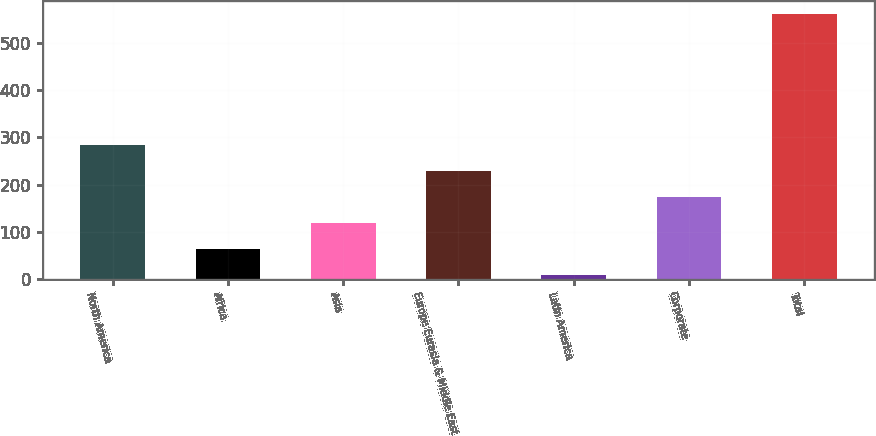Convert chart to OTSL. <chart><loc_0><loc_0><loc_500><loc_500><bar_chart><fcel>North America<fcel>Africa<fcel>Asia<fcel>Europe Eurasia & Middle East<fcel>Latin America<fcel>Corporate<fcel>Total<nl><fcel>284.5<fcel>63.3<fcel>118.6<fcel>229.2<fcel>8<fcel>173.9<fcel>561<nl></chart> 